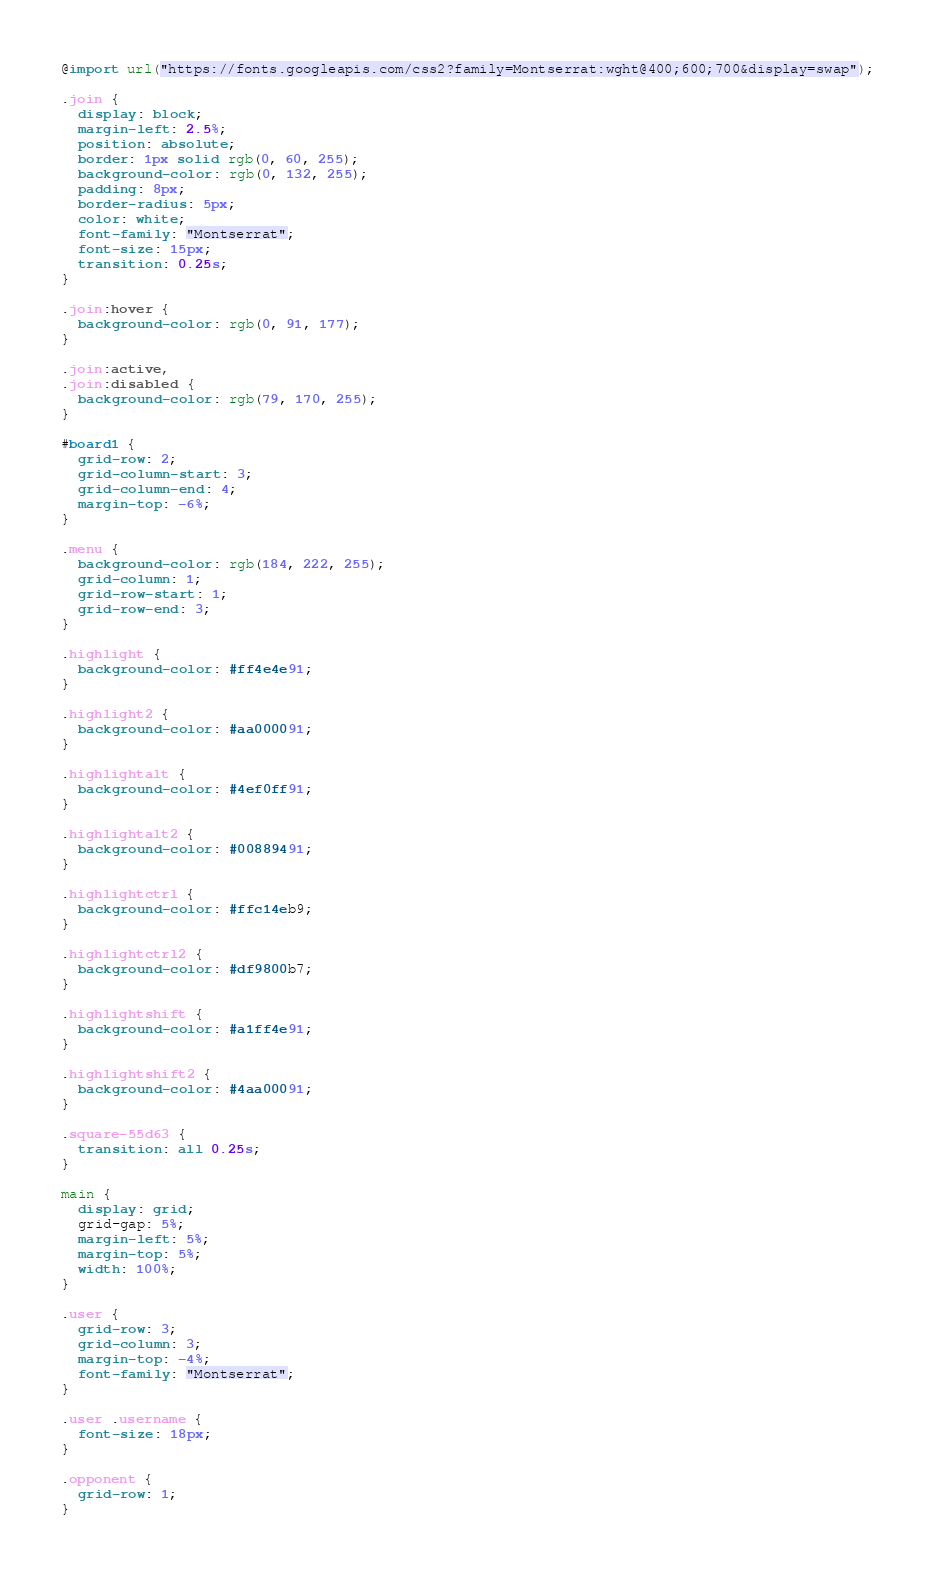<code> <loc_0><loc_0><loc_500><loc_500><_CSS_>@import url("https://fonts.googleapis.com/css2?family=Montserrat:wght@400;600;700&display=swap");

.join {
  display: block;
  margin-left: 2.5%;
  position: absolute;
  border: 1px solid rgb(0, 60, 255);
  background-color: rgb(0, 132, 255);
  padding: 8px;
  border-radius: 5px;
  color: white;
  font-family: "Montserrat";
  font-size: 15px;
  transition: 0.25s;
}

.join:hover {
  background-color: rgb(0, 91, 177);
}

.join:active,
.join:disabled {
  background-color: rgb(79, 170, 255);
}

#board1 {
  grid-row: 2;
  grid-column-start: 3;
  grid-column-end: 4;
  margin-top: -6%;
}

.menu {
  background-color: rgb(184, 222, 255);
  grid-column: 1;
  grid-row-start: 1;
  grid-row-end: 3;
}

.highlight {
  background-color: #ff4e4e91;
}

.highlight2 {
  background-color: #aa000091;
}

.highlightalt {
  background-color: #4ef0ff91;
}

.highlightalt2 {
  background-color: #00889491;
}

.highlightctrl {
  background-color: #ffc14eb9;
}

.highlightctrl2 {
  background-color: #df9800b7;
}

.highlightshift {
  background-color: #a1ff4e91;
}

.highlightshift2 {
  background-color: #4aa00091;
}

.square-55d63 {
  transition: all 0.25s;
}

main {
  display: grid;
  grid-gap: 5%;
  margin-left: 5%;
  margin-top: 5%;
  width: 100%;
}

.user {
  grid-row: 3;
  grid-column: 3;
  margin-top: -4%;
  font-family: "Montserrat";
}

.user .username {
  font-size: 18px;
}

.opponent {
  grid-row: 1;
}
</code> 